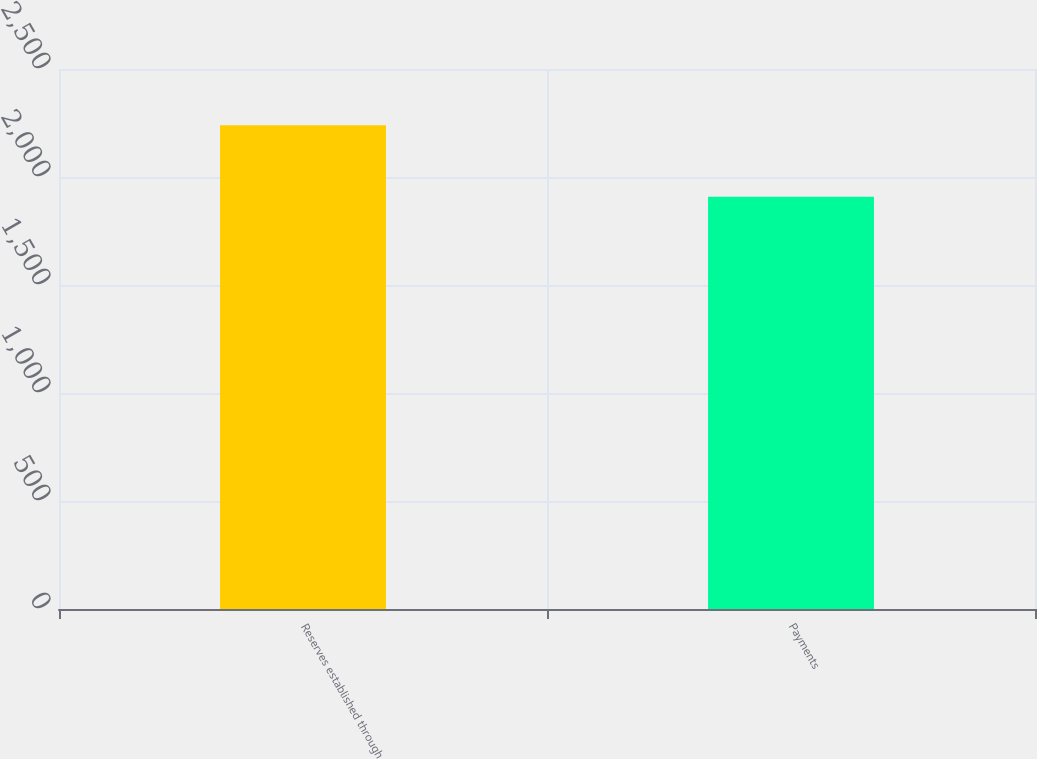Convert chart to OTSL. <chart><loc_0><loc_0><loc_500><loc_500><bar_chart><fcel>Reserves established through<fcel>Payments<nl><fcel>2240<fcel>1909<nl></chart> 